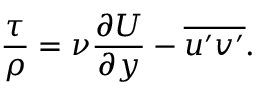Convert formula to latex. <formula><loc_0><loc_0><loc_500><loc_500>\frac { \tau } { \rho } = \nu \frac { \partial U } { \partial y } - \overline { { u ^ { \prime } v ^ { \prime } } } .</formula> 